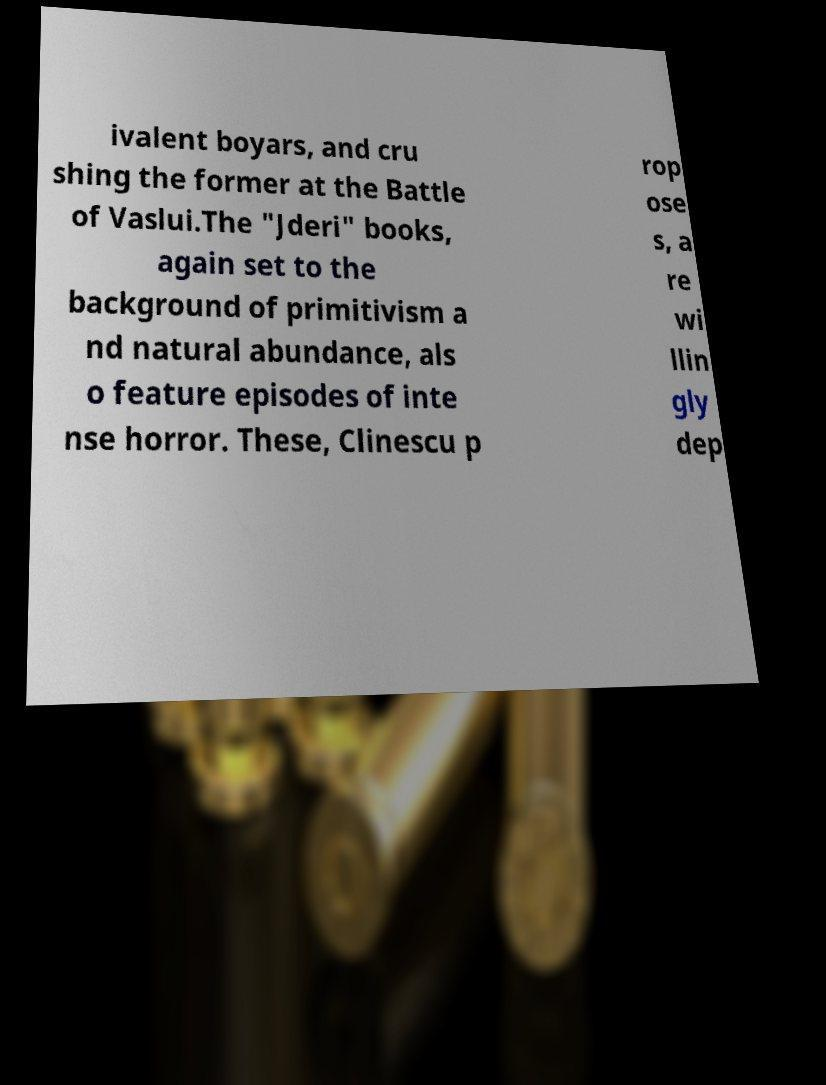I need the written content from this picture converted into text. Can you do that? ivalent boyars, and cru shing the former at the Battle of Vaslui.The "Jderi" books, again set to the background of primitivism a nd natural abundance, als o feature episodes of inte nse horror. These, Clinescu p rop ose s, a re wi llin gly dep 